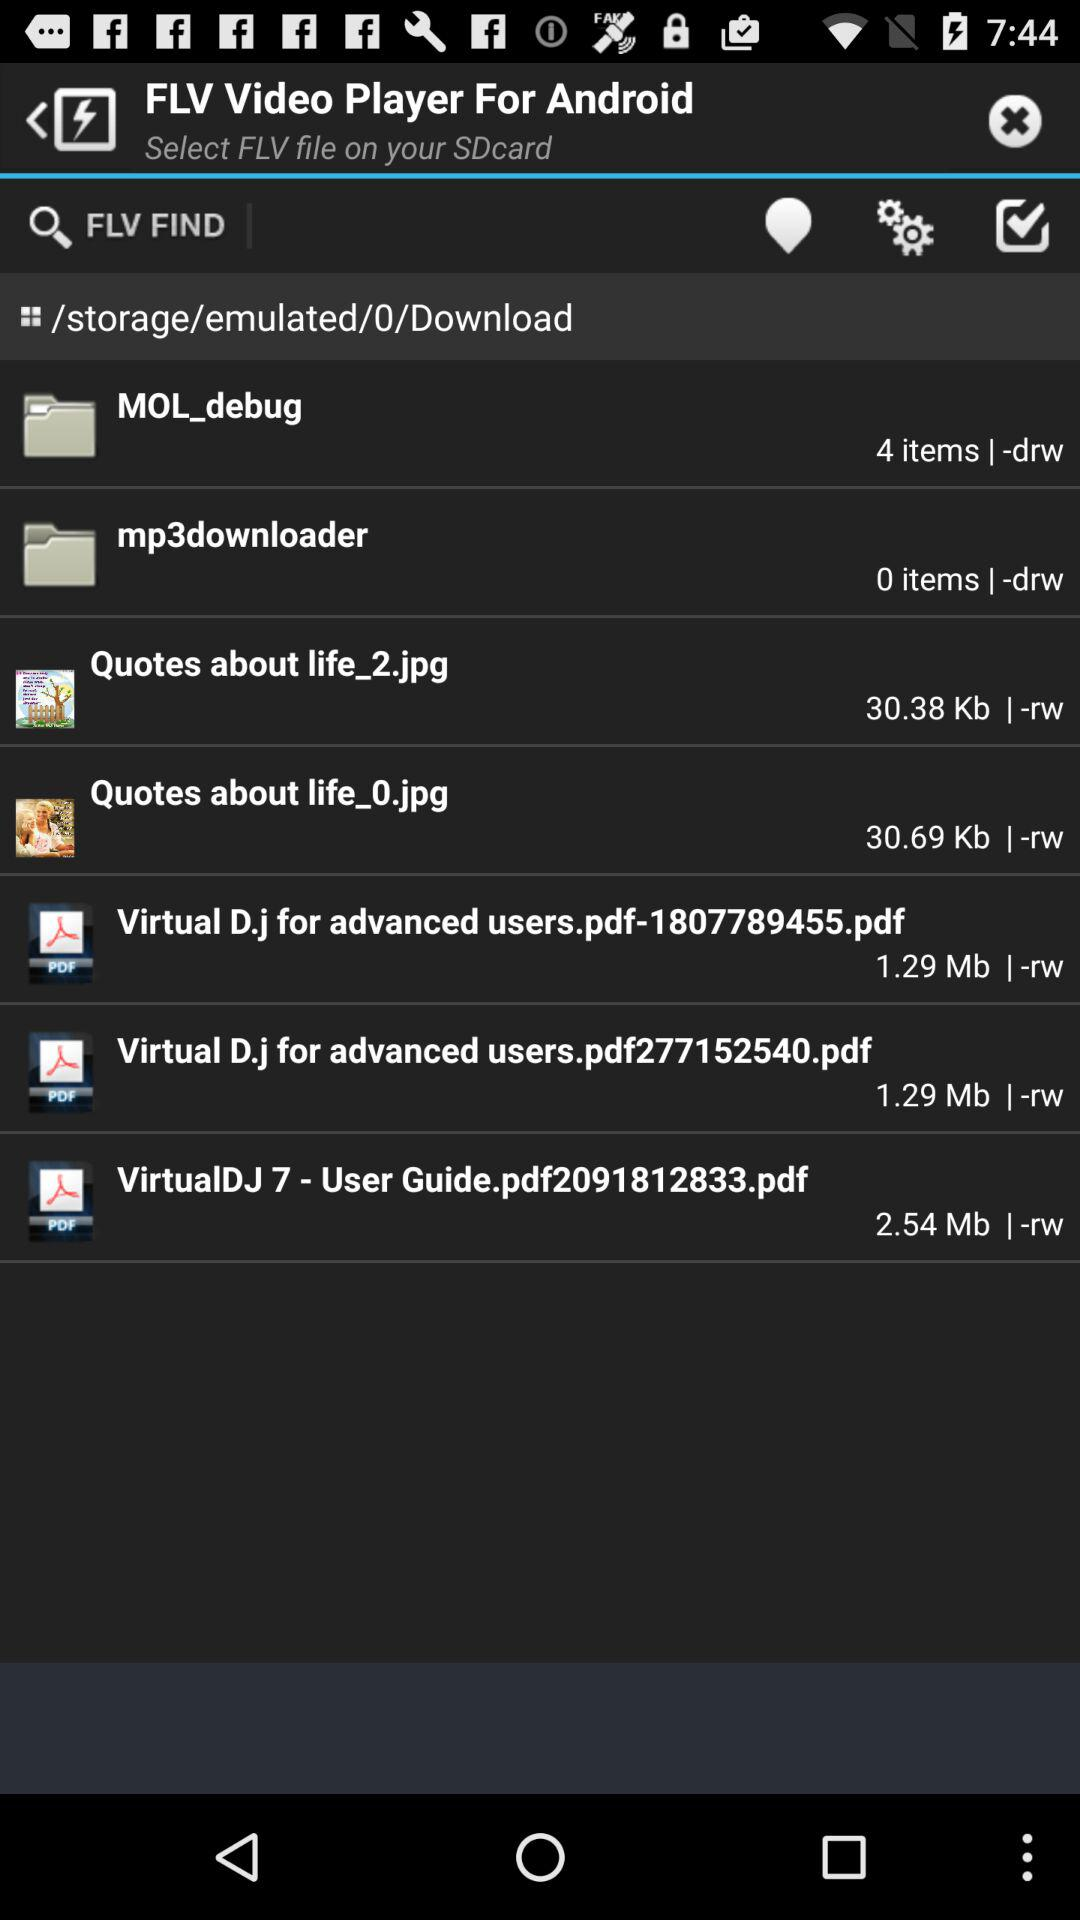How many items are in the MOL_debug folder?
Answer the question using a single word or phrase. 4 